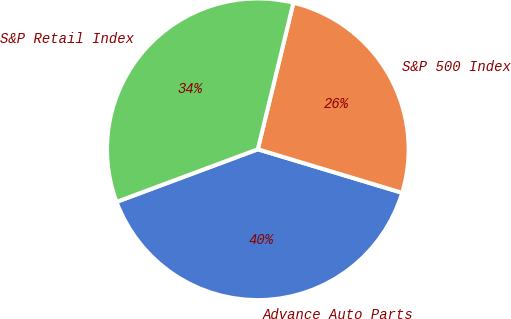Convert chart. <chart><loc_0><loc_0><loc_500><loc_500><pie_chart><fcel>Advance Auto Parts<fcel>S&P 500 Index<fcel>S&P Retail Index<nl><fcel>39.66%<fcel>25.87%<fcel>34.47%<nl></chart> 